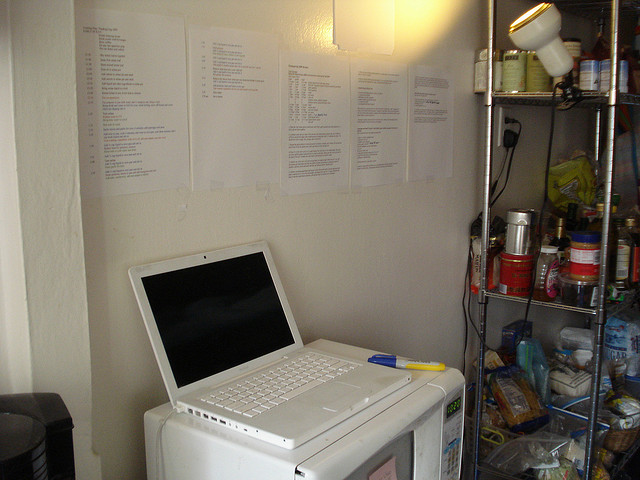Based on the arrangement of items, can you suggest what kind of area this might be? Given the combined presence of a laptop, microwave oven, coffee maker, and an assortment of food items on the shelf, this space likely serves as a dual-purpose area. It appears to be both a workspace and a storage or pantry area. The laptop suggests a place for work or study, while the food items and kitchen appliances indicate it is near or within a kitchen. This arrangement implies practicality, with essentials kept conveniently close for work or study. 